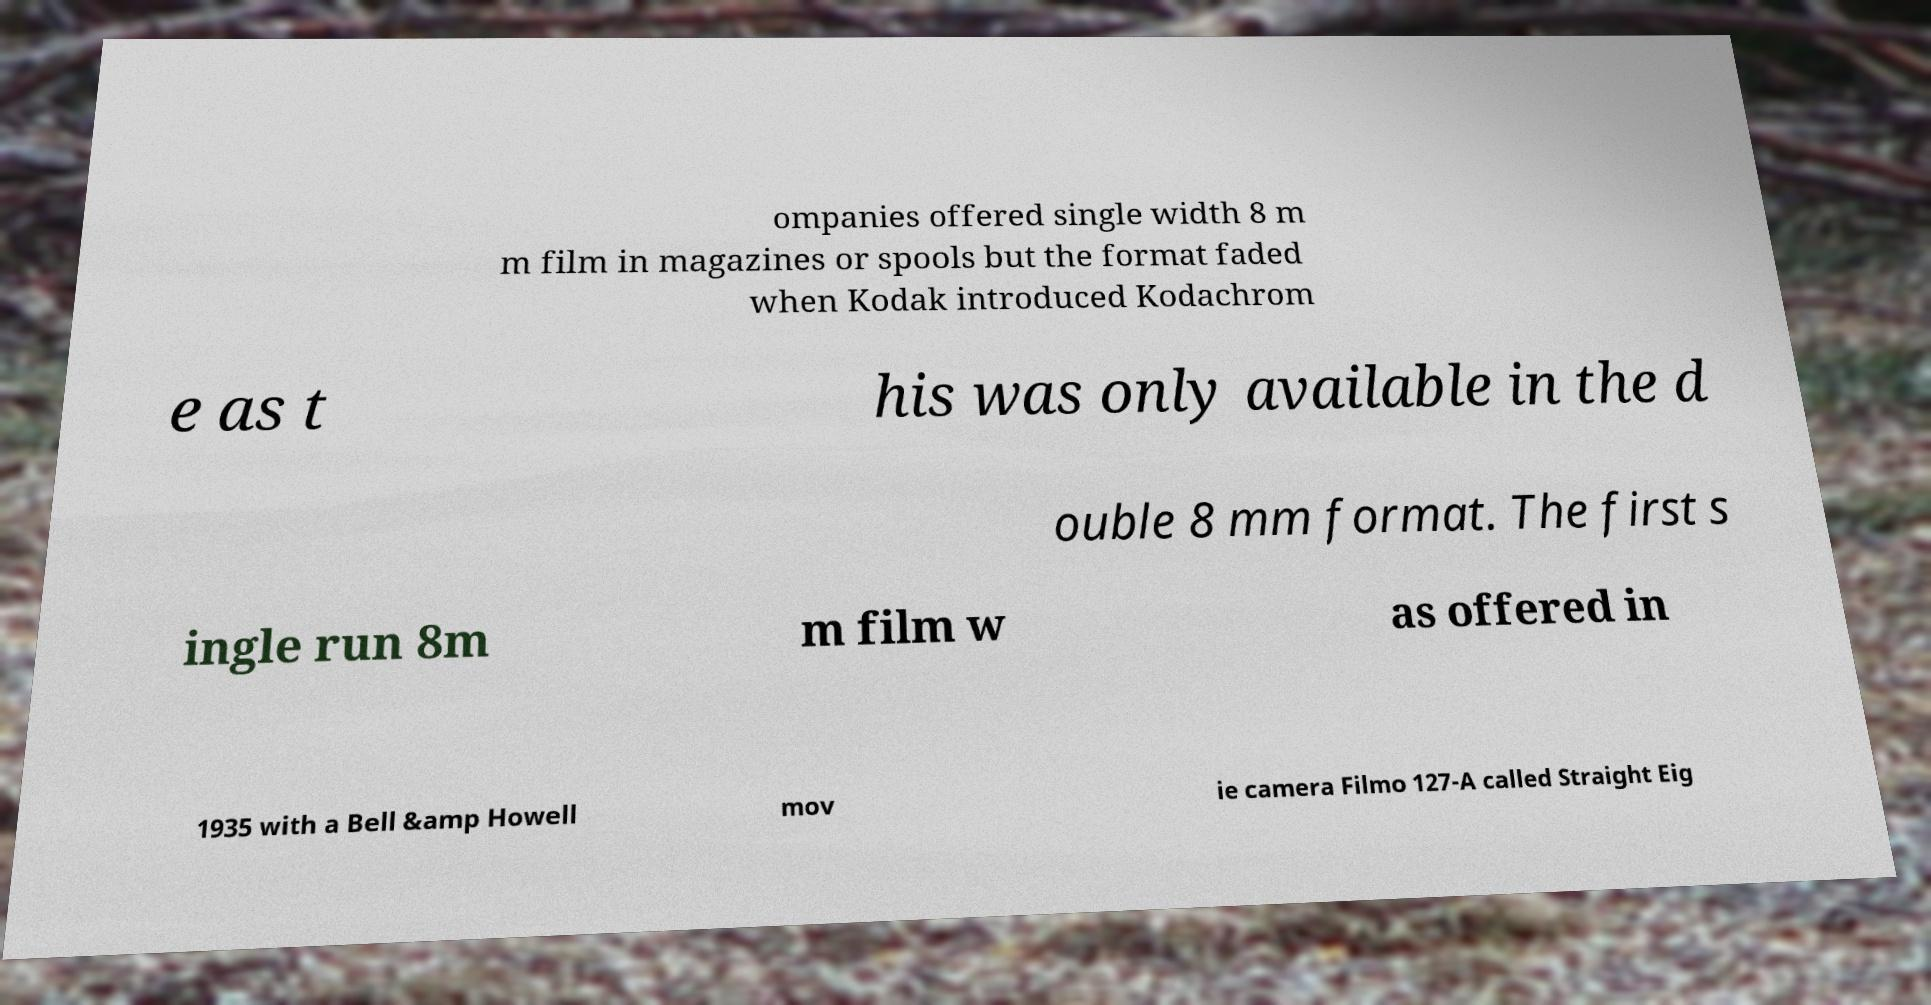Can you accurately transcribe the text from the provided image for me? ompanies offered single width 8 m m film in magazines or spools but the format faded when Kodak introduced Kodachrom e as t his was only available in the d ouble 8 mm format. The first s ingle run 8m m film w as offered in 1935 with a Bell &amp Howell mov ie camera Filmo 127-A called Straight Eig 